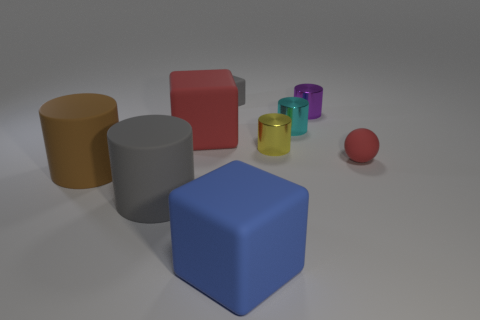Do the cyan metal cylinder and the gray block have the same size?
Offer a terse response. Yes. How big is the shiny cylinder that is in front of the small purple cylinder and behind the small yellow object?
Ensure brevity in your answer.  Small. Are there more cubes in front of the gray cube than big cubes behind the brown rubber cylinder?
Give a very brief answer. Yes. What color is the other matte object that is the same shape as the big gray object?
Your answer should be very brief. Brown. Do the large cube on the left side of the blue block and the matte ball have the same color?
Your answer should be compact. Yes. How many brown metallic cylinders are there?
Your answer should be very brief. 0. Does the red thing that is to the right of the tiny cyan metallic cylinder have the same material as the small purple cylinder?
Your answer should be compact. No. Are there any other things that are made of the same material as the tiny yellow object?
Offer a very short reply. Yes. What number of big brown objects are left of the big object that is to the right of the matte block that is behind the red cube?
Your response must be concise. 1. The blue matte thing has what size?
Offer a very short reply. Large. 